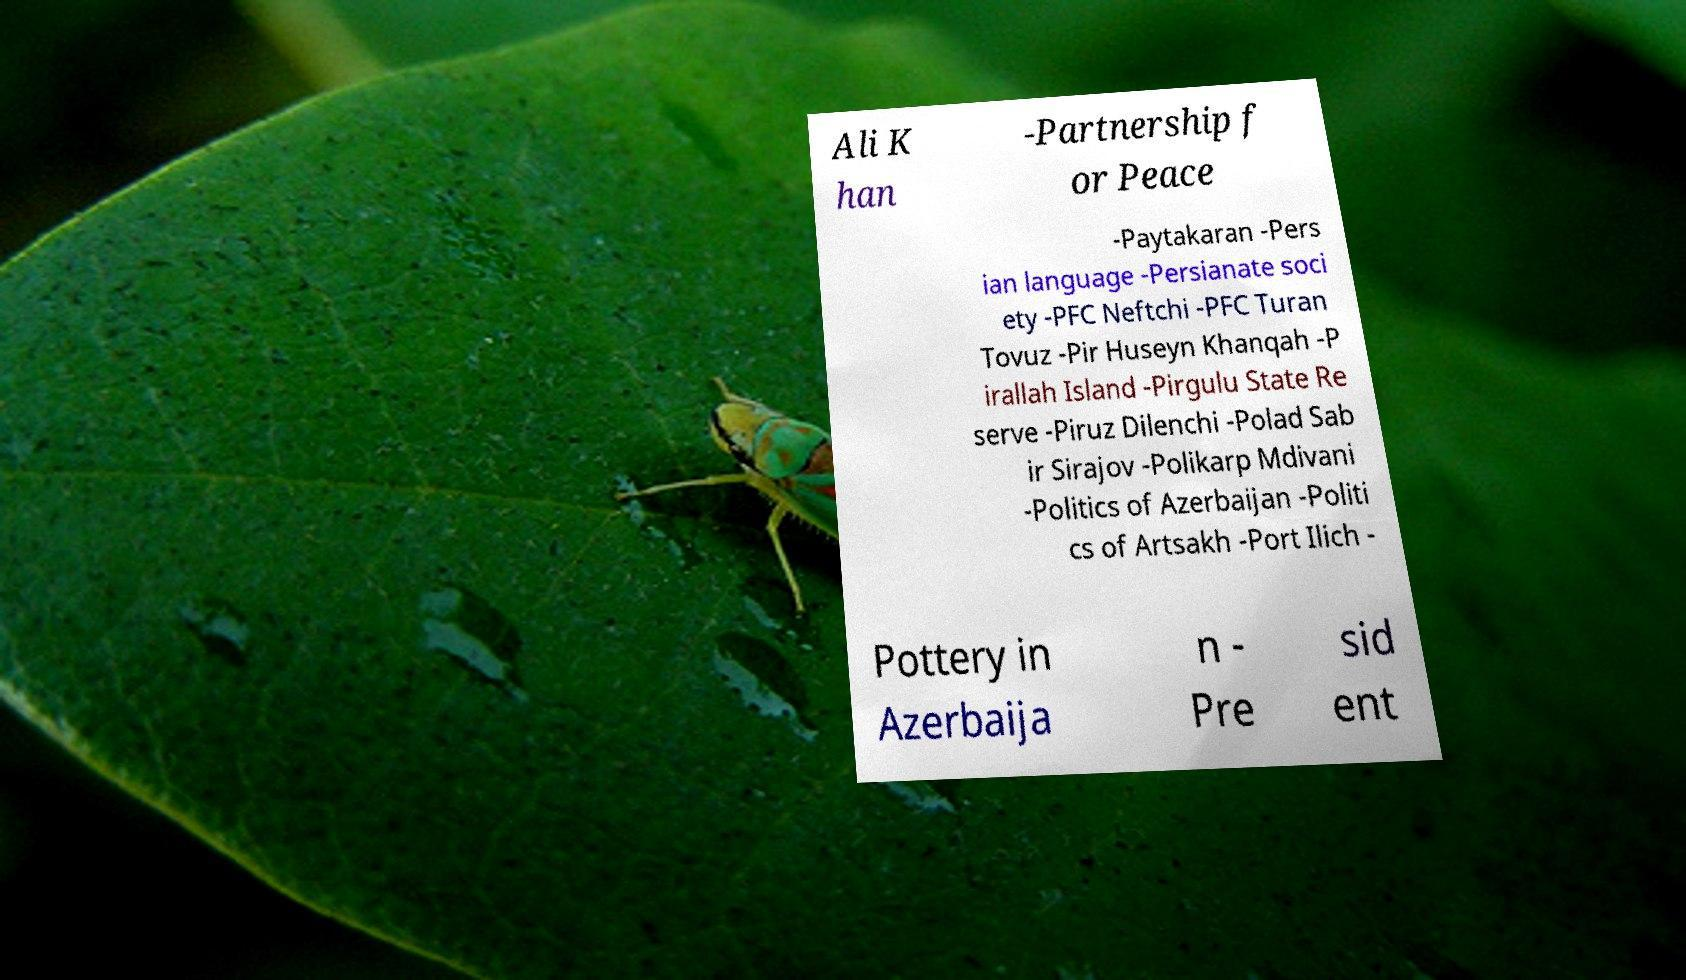What messages or text are displayed in this image? I need them in a readable, typed format. Ali K han -Partnership f or Peace -Paytakaran -Pers ian language -Persianate soci ety -PFC Neftchi -PFC Turan Tovuz -Pir Huseyn Khanqah -P irallah Island -Pirgulu State Re serve -Piruz Dilenchi -Polad Sab ir Sirajov -Polikarp Mdivani -Politics of Azerbaijan -Politi cs of Artsakh -Port Ilich - Pottery in Azerbaija n - Pre sid ent 